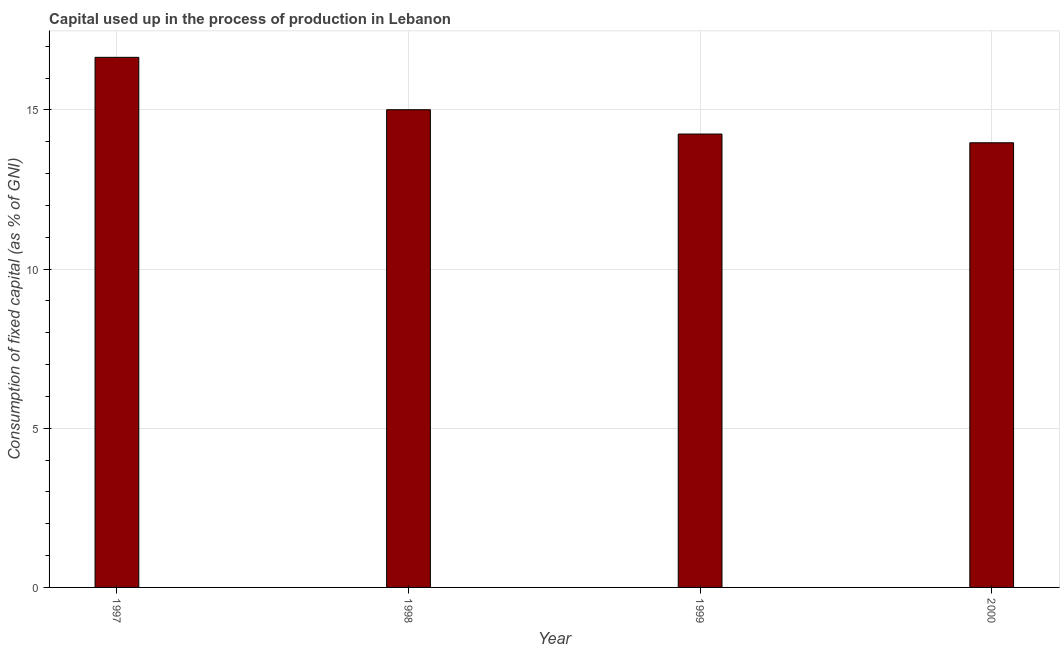Does the graph contain any zero values?
Keep it short and to the point. No. Does the graph contain grids?
Provide a short and direct response. Yes. What is the title of the graph?
Offer a terse response. Capital used up in the process of production in Lebanon. What is the label or title of the X-axis?
Your answer should be compact. Year. What is the label or title of the Y-axis?
Keep it short and to the point. Consumption of fixed capital (as % of GNI). What is the consumption of fixed capital in 1997?
Ensure brevity in your answer.  16.65. Across all years, what is the maximum consumption of fixed capital?
Make the answer very short. 16.65. Across all years, what is the minimum consumption of fixed capital?
Keep it short and to the point. 13.97. In which year was the consumption of fixed capital minimum?
Provide a succinct answer. 2000. What is the sum of the consumption of fixed capital?
Make the answer very short. 59.87. What is the difference between the consumption of fixed capital in 1999 and 2000?
Your answer should be compact. 0.27. What is the average consumption of fixed capital per year?
Offer a very short reply. 14.97. What is the median consumption of fixed capital?
Keep it short and to the point. 14.62. In how many years, is the consumption of fixed capital greater than 8 %?
Your answer should be very brief. 4. What is the ratio of the consumption of fixed capital in 1997 to that in 1999?
Provide a succinct answer. 1.17. Is the consumption of fixed capital in 1997 less than that in 1999?
Offer a terse response. No. Is the difference between the consumption of fixed capital in 1997 and 2000 greater than the difference between any two years?
Give a very brief answer. Yes. What is the difference between the highest and the second highest consumption of fixed capital?
Ensure brevity in your answer.  1.65. Is the sum of the consumption of fixed capital in 1999 and 2000 greater than the maximum consumption of fixed capital across all years?
Your answer should be very brief. Yes. What is the difference between the highest and the lowest consumption of fixed capital?
Make the answer very short. 2.68. In how many years, is the consumption of fixed capital greater than the average consumption of fixed capital taken over all years?
Offer a terse response. 2. How many years are there in the graph?
Make the answer very short. 4. What is the difference between two consecutive major ticks on the Y-axis?
Offer a very short reply. 5. Are the values on the major ticks of Y-axis written in scientific E-notation?
Make the answer very short. No. What is the Consumption of fixed capital (as % of GNI) in 1997?
Keep it short and to the point. 16.65. What is the Consumption of fixed capital (as % of GNI) of 1998?
Provide a succinct answer. 15.01. What is the Consumption of fixed capital (as % of GNI) in 1999?
Ensure brevity in your answer.  14.24. What is the Consumption of fixed capital (as % of GNI) in 2000?
Ensure brevity in your answer.  13.97. What is the difference between the Consumption of fixed capital (as % of GNI) in 1997 and 1998?
Provide a short and direct response. 1.65. What is the difference between the Consumption of fixed capital (as % of GNI) in 1997 and 1999?
Provide a short and direct response. 2.41. What is the difference between the Consumption of fixed capital (as % of GNI) in 1997 and 2000?
Ensure brevity in your answer.  2.68. What is the difference between the Consumption of fixed capital (as % of GNI) in 1998 and 1999?
Your answer should be compact. 0.76. What is the difference between the Consumption of fixed capital (as % of GNI) in 1998 and 2000?
Make the answer very short. 1.04. What is the difference between the Consumption of fixed capital (as % of GNI) in 1999 and 2000?
Make the answer very short. 0.27. What is the ratio of the Consumption of fixed capital (as % of GNI) in 1997 to that in 1998?
Keep it short and to the point. 1.11. What is the ratio of the Consumption of fixed capital (as % of GNI) in 1997 to that in 1999?
Make the answer very short. 1.17. What is the ratio of the Consumption of fixed capital (as % of GNI) in 1997 to that in 2000?
Provide a succinct answer. 1.19. What is the ratio of the Consumption of fixed capital (as % of GNI) in 1998 to that in 1999?
Offer a very short reply. 1.05. What is the ratio of the Consumption of fixed capital (as % of GNI) in 1998 to that in 2000?
Give a very brief answer. 1.07. 